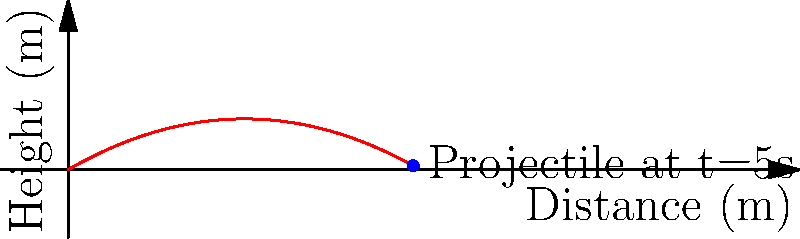A 17th-century Russian cannon fires a cannonball with an initial velocity of 50 m/s at an angle of 30° above the horizontal. Assuming no air resistance, what is the height of the cannonball after 5 seconds? To solve this problem, we'll use the equation for the vertical displacement of a projectile:

$$y = v_0y \cdot t - \frac{1}{2}gt^2$$

Where:
- $y$ is the vertical displacement (height)
- $v_0y$ is the initial vertical velocity
- $t$ is the time
- $g$ is the acceleration due to gravity (9.8 m/s²)

Steps:
1) First, calculate the initial vertical velocity:
   $$v_0y = v_0 \sin \theta = 50 \cdot \sin 30° = 25 \text{ m/s}$$

2) Now, plug all values into the equation:
   $$y = (25 \text{ m/s}) \cdot (5 \text{ s}) - \frac{1}{2}(9.8 \text{ m/s}^2)(5 \text{ s})^2$$

3) Solve:
   $$y = 125 \text{ m} - \frac{1}{2}(9.8)(25) \text{ m}$$
   $$y = 125 \text{ m} - 122.5 \text{ m}$$
   $$y = 2.5 \text{ m}$$

Therefore, after 5 seconds, the cannonball will be at a height of 2.5 meters.
Answer: 2.5 m 